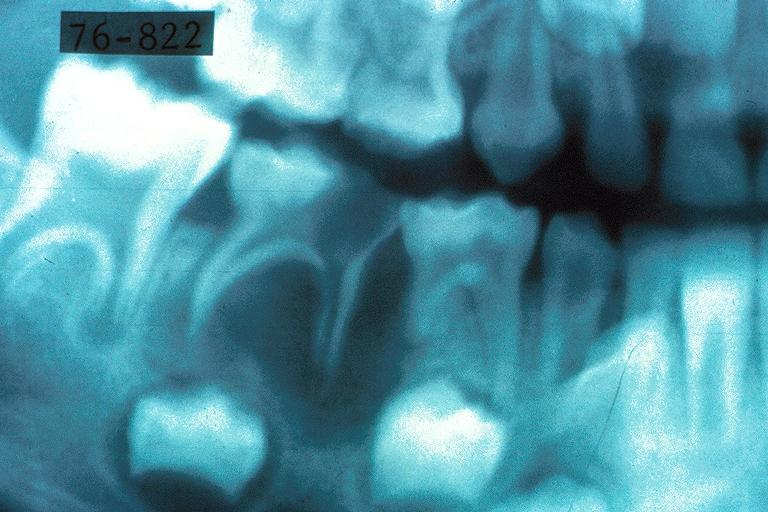s oral present?
Answer the question using a single word or phrase. Yes 